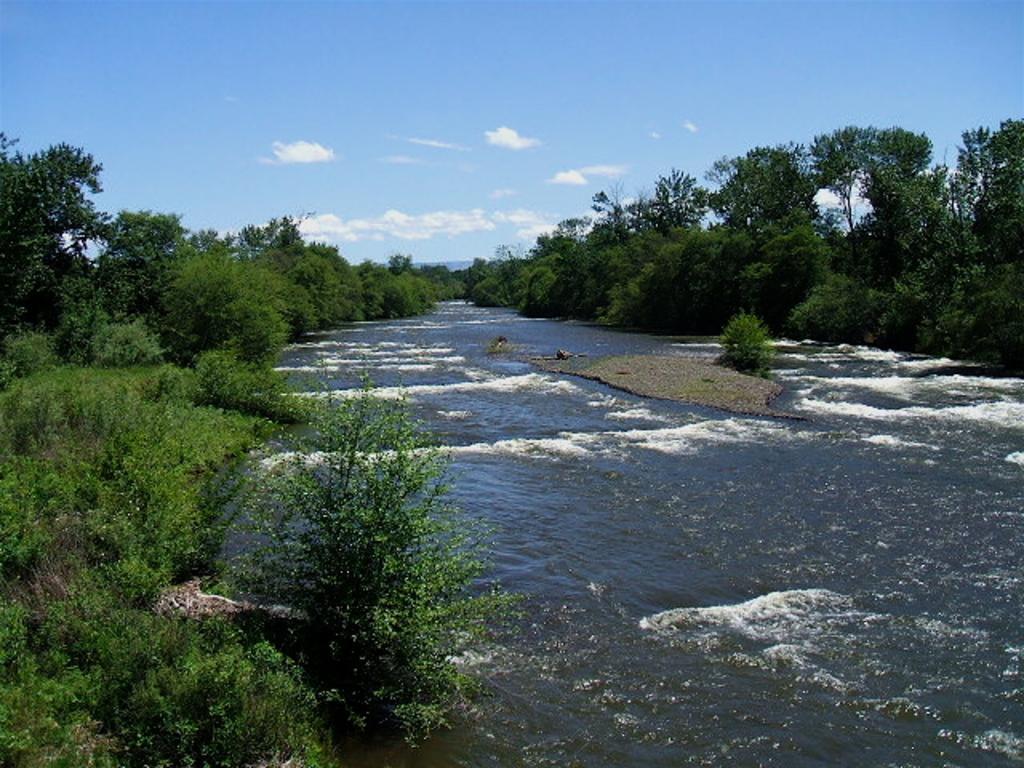In one or two sentences, can you explain what this image depicts? In the picture we can see water, on the either sides of the water we can see plants and in the background, we can see trees, hill and sky with clouds. 